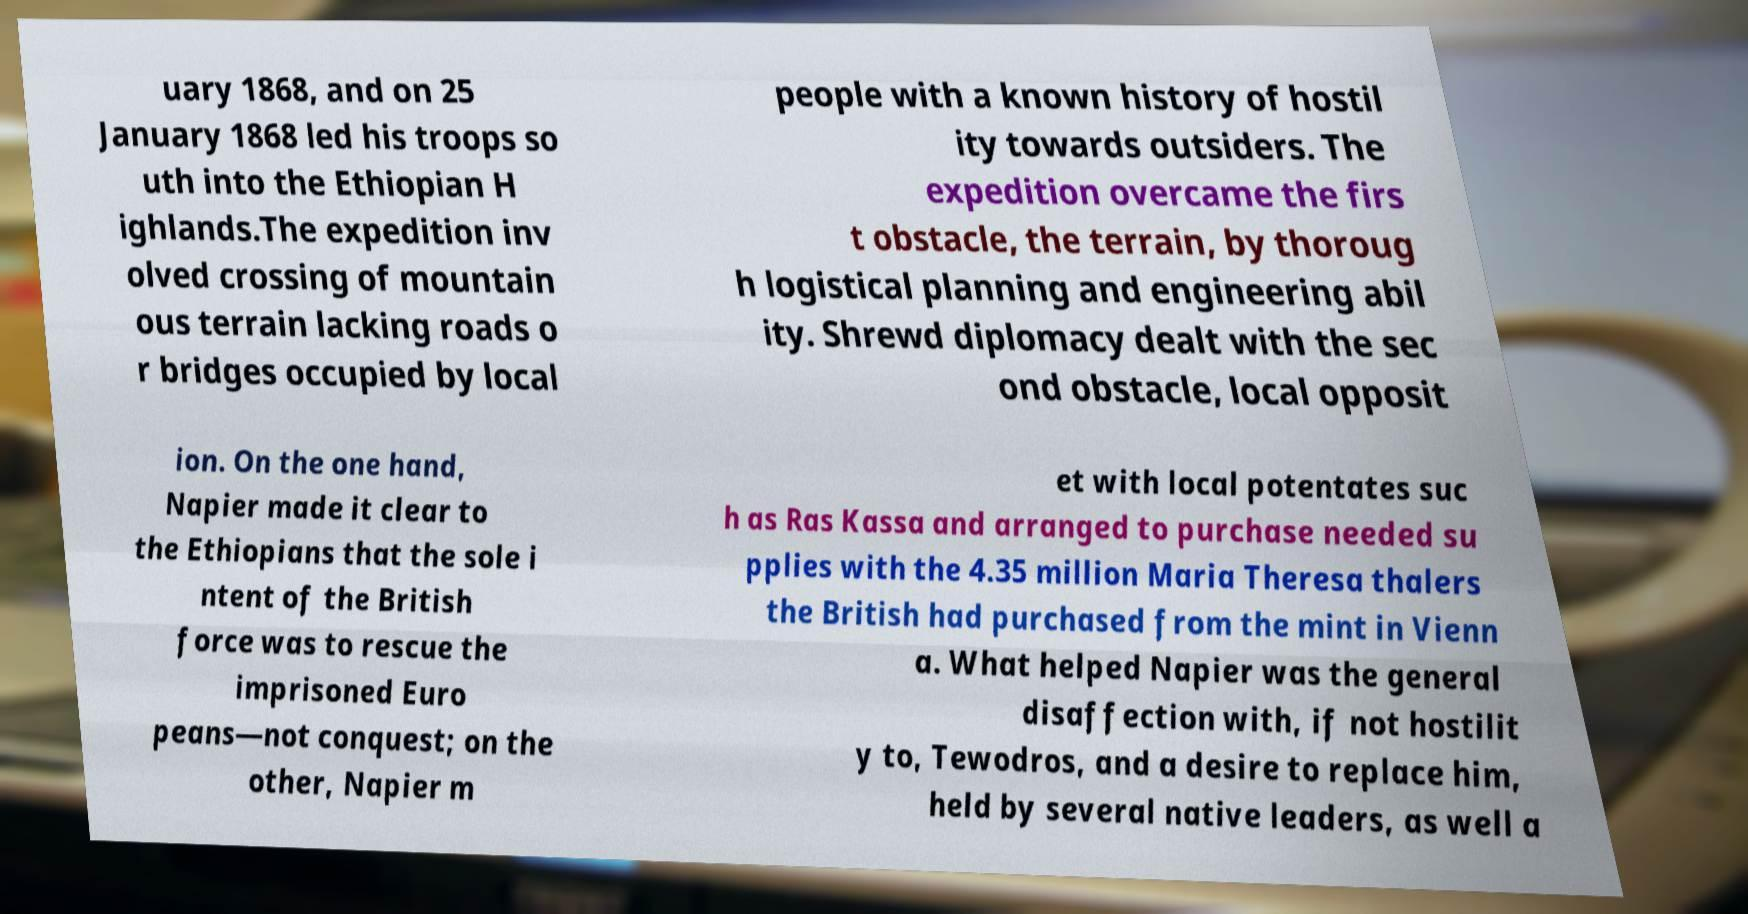Could you extract and type out the text from this image? uary 1868, and on 25 January 1868 led his troops so uth into the Ethiopian H ighlands.The expedition inv olved crossing of mountain ous terrain lacking roads o r bridges occupied by local people with a known history of hostil ity towards outsiders. The expedition overcame the firs t obstacle, the terrain, by thoroug h logistical planning and engineering abil ity. Shrewd diplomacy dealt with the sec ond obstacle, local opposit ion. On the one hand, Napier made it clear to the Ethiopians that the sole i ntent of the British force was to rescue the imprisoned Euro peans—not conquest; on the other, Napier m et with local potentates suc h as Ras Kassa and arranged to purchase needed su pplies with the 4.35 million Maria Theresa thalers the British had purchased from the mint in Vienn a. What helped Napier was the general disaffection with, if not hostilit y to, Tewodros, and a desire to replace him, held by several native leaders, as well a 